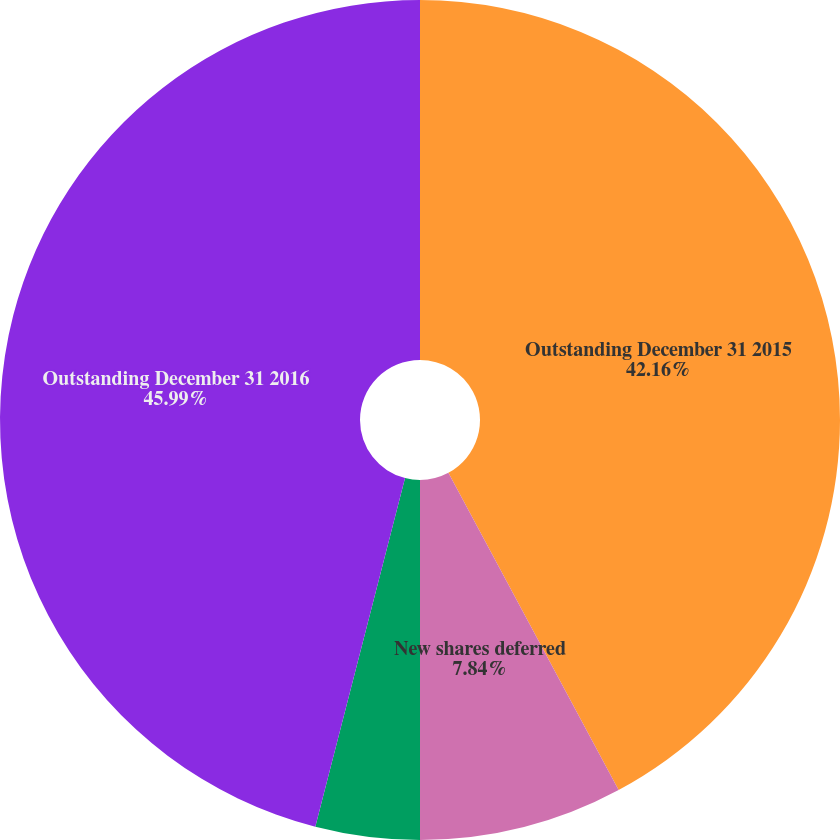Convert chart to OTSL. <chart><loc_0><loc_0><loc_500><loc_500><pie_chart><fcel>Outstanding December 31 2015<fcel>New shares deferred<fcel>Issued<fcel>Outstanding December 31 2016<nl><fcel>42.16%<fcel>7.84%<fcel>4.01%<fcel>45.99%<nl></chart> 